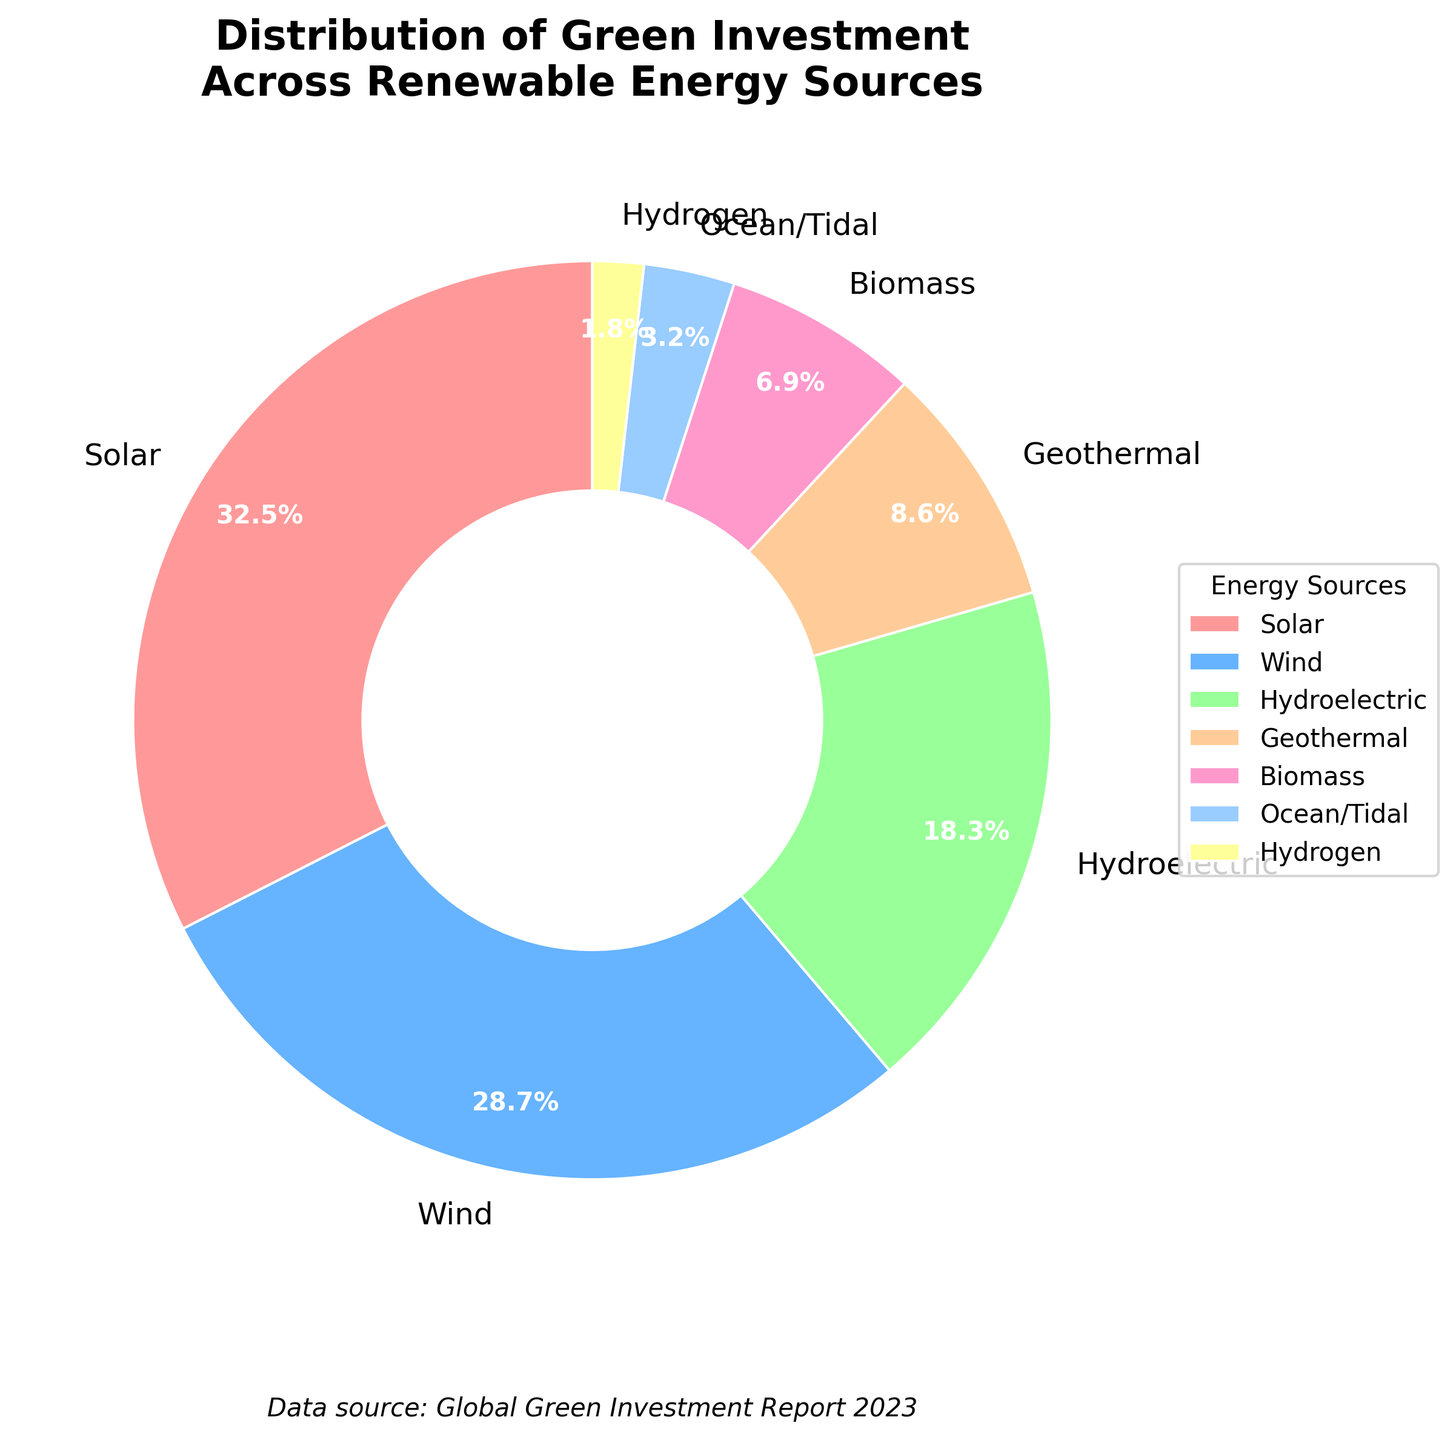What percentage of green investment is allocated to solar energy? The figure shows that solar energy has a label indicating 32.5%.
Answer: 32.5% Which renewable energy source receives the second highest investment? The figure indicates that wind energy occupies the second largest wedge, labeled with 28.7%.
Answer: Wind How much more investment does solar energy receive compared to biomass? Solar energy investment is 32.5%, and biomass is 6.9%. The difference is 32.5 - 6.9 = 25.6%.
Answer: 25.6% What is the combined investment percentage of hydroelectric and geothermal energy? Hydroelectric investment is 18.3% and geothermal is 8.6%. Combined, it is 18.3 + 8.6 = 26.9%.
Answer: 26.9% Which energy sources receive less than 10% of the total investment? The figure shows that geothermal, biomass, ocean/tidal, and hydrogen are under 10%. Their investments are 8.6%, 6.9%, 3.2%, and 1.8% respectively.
Answer: Geothermal, Biomass, Ocean/Tidal, Hydrogen Are there more investments in wind energy or the combined investments of ocean/tidal and hydrogen? Investment in wind energy is 28.7%. Combined investments of ocean/tidal and hydrogen are 3.2% + 1.8% = 5.0%. 28.7% is greater than 5.0%.
Answer: Wind energy What is the visual indicator used in the pie chart to denote biomass energy investment? The pie chart uses a pinkish shade to represent biomass energy, labeled with 6.9%.
Answer: Pinkish shade Is the investment in hydroelectric energy less than the combined investment in wind and solar energy? Hydroelectric energy has 18.3%. Combined wind and solar investments are 32.5% + 28.7% = 61.2%. 18.3% is less than 61.2%.
Answer: Yes What is the smallest investment percentage shown in the pie chart and which energy source does it represent? The pie chart designates hydrogen energy with the smallest investment percentage of 1.8%.
Answer: 1.8%, Hydrogen 